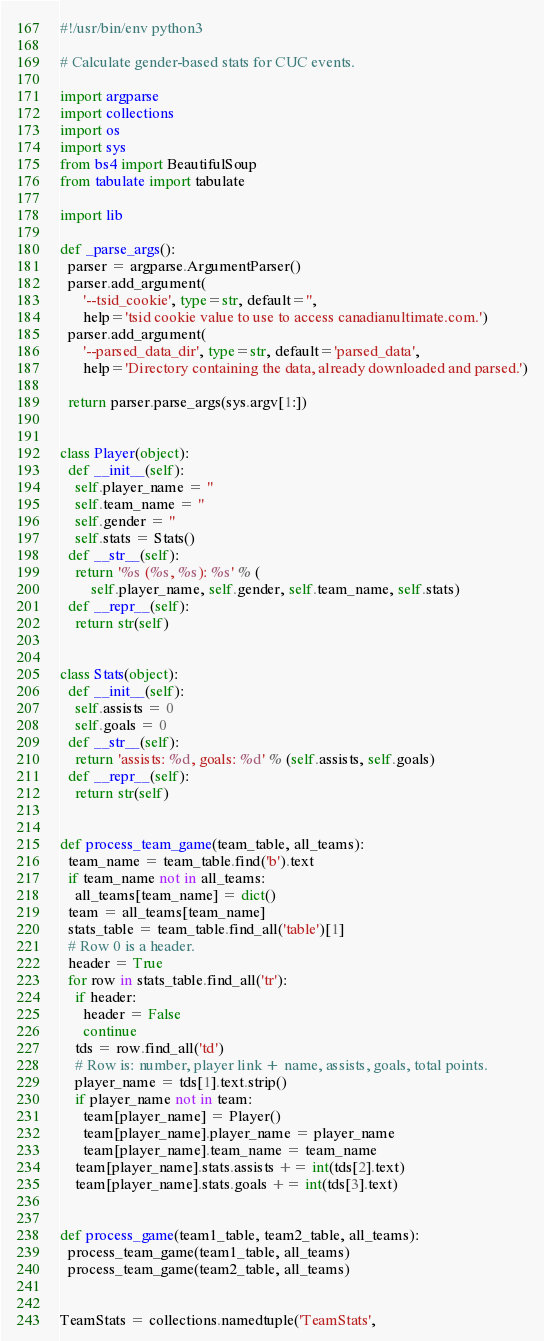<code> <loc_0><loc_0><loc_500><loc_500><_Python_>#!/usr/bin/env python3

# Calculate gender-based stats for CUC events.

import argparse
import collections
import os
import sys
from bs4 import BeautifulSoup
from tabulate import tabulate

import lib

def _parse_args():
  parser = argparse.ArgumentParser()
  parser.add_argument(
      '--tsid_cookie', type=str, default='',
      help='tsid cookie value to use to access canadianultimate.com.')
  parser.add_argument(
      '--parsed_data_dir', type=str, default='parsed_data',
      help='Directory containing the data, already downloaded and parsed.')

  return parser.parse_args(sys.argv[1:])


class Player(object):
  def __init__(self):
    self.player_name = ''
    self.team_name = ''
    self.gender = ''
    self.stats = Stats()
  def __str__(self):
    return '%s (%s, %s): %s' % (
        self.player_name, self.gender, self.team_name, self.stats)
  def __repr__(self):
    return str(self)


class Stats(object):
  def __init__(self):
    self.assists = 0
    self.goals = 0
  def __str__(self):
    return 'assists: %d, goals: %d' % (self.assists, self.goals)
  def __repr__(self):
    return str(self)


def process_team_game(team_table, all_teams):
  team_name = team_table.find('b').text
  if team_name not in all_teams:
    all_teams[team_name] = dict()
  team = all_teams[team_name]
  stats_table = team_table.find_all('table')[1]
  # Row 0 is a header.
  header = True
  for row in stats_table.find_all('tr'):
    if header:
      header = False
      continue
    tds = row.find_all('td')
    # Row is: number, player link + name, assists, goals, total points.
    player_name = tds[1].text.strip()
    if player_name not in team:
      team[player_name] = Player()
      team[player_name].player_name = player_name
      team[player_name].team_name = team_name
    team[player_name].stats.assists += int(tds[2].text)
    team[player_name].stats.goals += int(tds[3].text)


def process_game(team1_table, team2_table, all_teams):
  process_team_game(team1_table, all_teams)
  process_team_game(team2_table, all_teams)


TeamStats = collections.namedtuple('TeamStats',</code> 